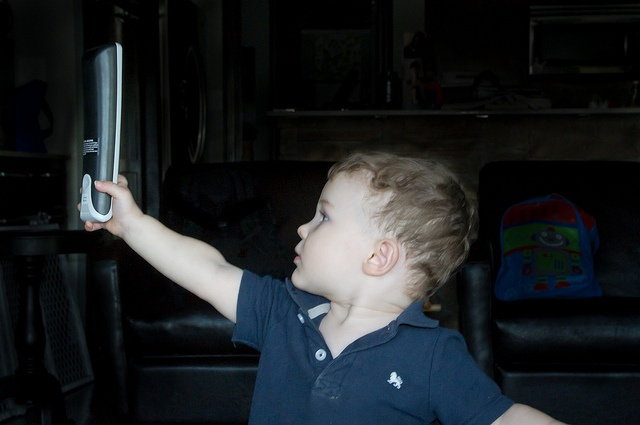Describe the objects in this image and their specific colors. I can see people in black, darkblue, lightgray, and darkgray tones, chair in black and navy tones, chair in black, darkblue, blue, and darkgray tones, microwave in black tones, and remote in black, gray, and blue tones in this image. 